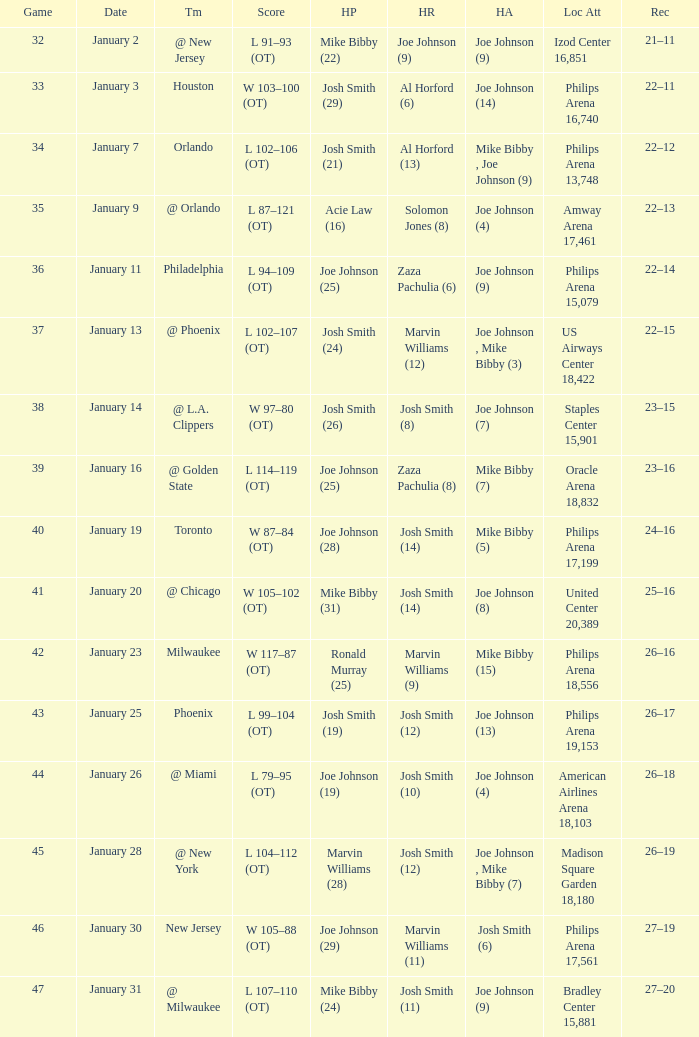What was the record after game 37? 22–15. 